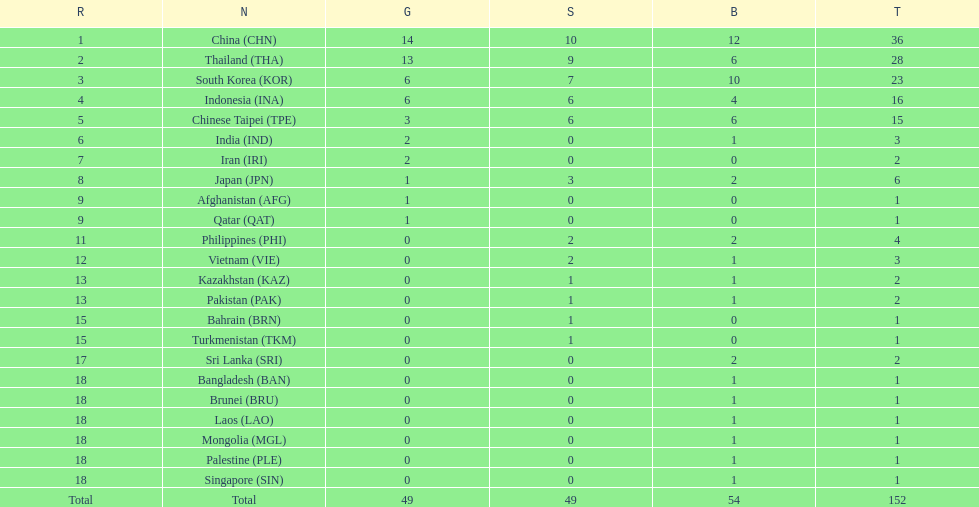Which nation finished first in total medals earned? China (CHN). 